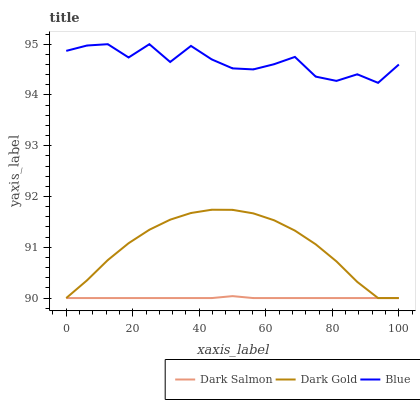Does Dark Salmon have the minimum area under the curve?
Answer yes or no. Yes. Does Blue have the maximum area under the curve?
Answer yes or no. Yes. Does Dark Gold have the minimum area under the curve?
Answer yes or no. No. Does Dark Gold have the maximum area under the curve?
Answer yes or no. No. Is Dark Salmon the smoothest?
Answer yes or no. Yes. Is Blue the roughest?
Answer yes or no. Yes. Is Dark Gold the smoothest?
Answer yes or no. No. Is Dark Gold the roughest?
Answer yes or no. No. Does Dark Salmon have the lowest value?
Answer yes or no. Yes. Does Blue have the highest value?
Answer yes or no. Yes. Does Dark Gold have the highest value?
Answer yes or no. No. Is Dark Gold less than Blue?
Answer yes or no. Yes. Is Blue greater than Dark Gold?
Answer yes or no. Yes. Does Dark Gold intersect Dark Salmon?
Answer yes or no. Yes. Is Dark Gold less than Dark Salmon?
Answer yes or no. No. Is Dark Gold greater than Dark Salmon?
Answer yes or no. No. Does Dark Gold intersect Blue?
Answer yes or no. No. 